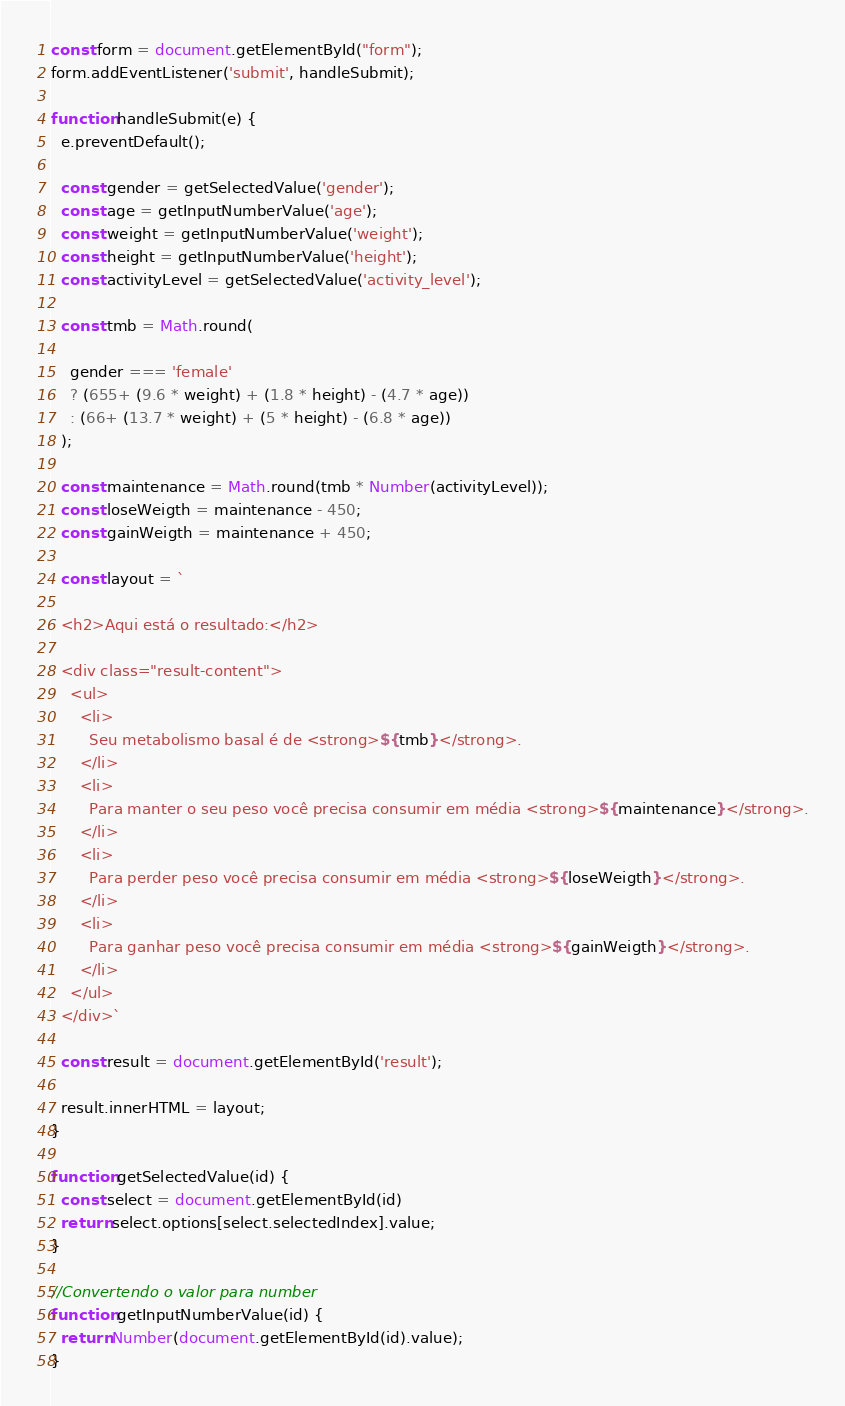<code> <loc_0><loc_0><loc_500><loc_500><_JavaScript_>const form = document.getElementById("form");
form.addEventListener('submit', handleSubmit);

function handleSubmit(e) {
  e.preventDefault();

  const gender = getSelectedValue('gender');
  const age = getInputNumberValue('age');
  const weight = getInputNumberValue('weight');
  const height = getInputNumberValue('height');
  const activityLevel = getSelectedValue('activity_level');

  const tmb = Math.round(

    gender === 'female'
    ? (655+ (9.6 * weight) + (1.8 * height) - (4.7 * age))
    : (66+ (13.7 * weight) + (5 * height) - (6.8 * age))
  );

  const maintenance = Math.round(tmb * Number(activityLevel));
  const loseWeigth = maintenance - 450;
  const gainWeigth = maintenance + 450;

  const layout = ` 
  
  <h2>Aqui está o resultado:</h2>

  <div class="result-content">
    <ul>
      <li>
        Seu metabolismo basal é de <strong>${tmb}</strong>.
      </li>
      <li>
        Para manter o seu peso você precisa consumir em média <strong>${maintenance}</strong>.
      </li>
      <li>
        Para perder peso você precisa consumir em média <strong>${loseWeigth}</strong>.
      </li>
      <li>
        Para ganhar peso você precisa consumir em média <strong>${gainWeigth}</strong>.
      </li>
    </ul>
  </div>`

  const result = document.getElementById('result');

  result.innerHTML = layout;
}

function getSelectedValue(id) {
  const select = document.getElementById(id)
  return select.options[select.selectedIndex].value;
}

//Convertendo o valor para number
function getInputNumberValue(id) {
  return Number(document.getElementById(id).value);
}</code> 